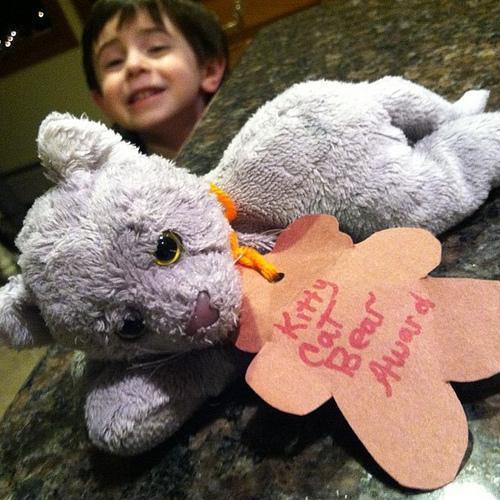How many children are shown?
Give a very brief answer. 1. 